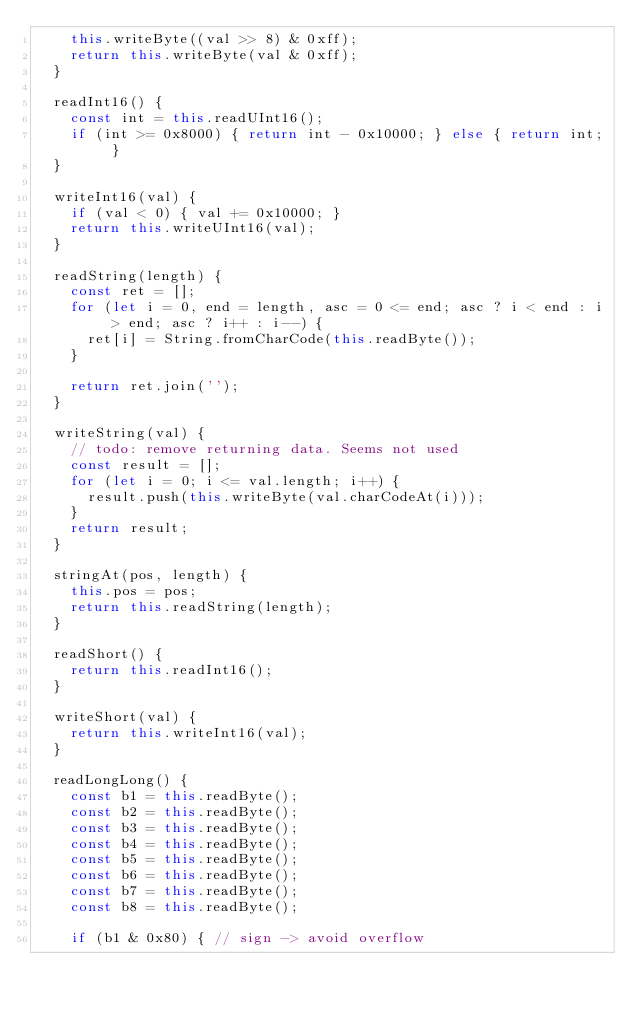Convert code to text. <code><loc_0><loc_0><loc_500><loc_500><_JavaScript_>    this.writeByte((val >> 8) & 0xff);
    return this.writeByte(val & 0xff);
  }
    
  readInt16() {
    const int = this.readUInt16();
    if (int >= 0x8000) { return int - 0x10000; } else { return int; }
  }
    
  writeInt16(val) {
    if (val < 0) { val += 0x10000; }
    return this.writeUInt16(val);
  }
    
  readString(length) {
    const ret = [];
    for (let i = 0, end = length, asc = 0 <= end; asc ? i < end : i > end; asc ? i++ : i--) {
      ret[i] = String.fromCharCode(this.readByte());
    }
      
    return ret.join('');
  }
    
  writeString(val) {
    // todo: remove returning data. Seems not used
    const result = [];
    for (let i = 0; i <= val.length; i++) {
      result.push(this.writeByte(val.charCodeAt(i)));
    }
    return result;
  }
    
  stringAt(pos, length) {
    this.pos = pos;
    return this.readString(length);
  }
    
  readShort() {
    return this.readInt16();
  }
    
  writeShort(val) {
    return this.writeInt16(val);
  }
  
  readLongLong() {
    const b1 = this.readByte();
    const b2 = this.readByte();
    const b3 = this.readByte();
    const b4 = this.readByte();
    const b5 = this.readByte();
    const b6 = this.readByte();
    const b7 = this.readByte();
    const b8 = this.readByte();
    
    if (b1 & 0x80) { // sign -> avoid overflow</code> 